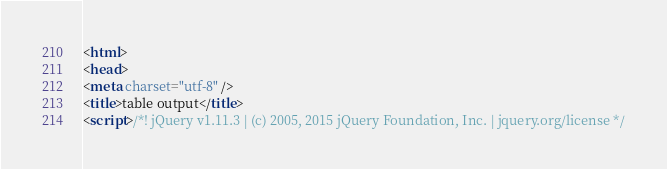<code> <loc_0><loc_0><loc_500><loc_500><_HTML_><html>
<head>
<meta charset="utf-8" />
<title>table output</title>
<script>/*! jQuery v1.11.3 | (c) 2005, 2015 jQuery Foundation, Inc. | jquery.org/license */</code> 